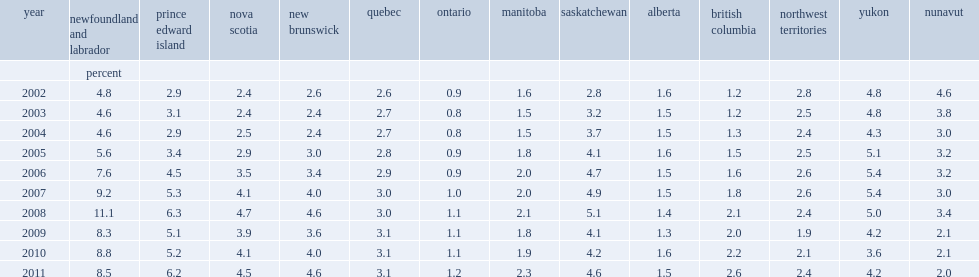What is the percentage of the total wages and salaries that is earned in 2011 by all employees residing in newfoundland and labrador coming from interprovincial employment? 8.5. What is the percentage of the total wages and salaries that is earned in 2011 by all employees residing in prince edward island coming from interprovincial employment? 6.2. What is the percentage of the total wages and salaries that is earned in 2011 by all employees residing in nova scotia coming from interprovincial employment? 4.5. What is the percentage of the total wages and salaries that is earned in 2011 by all employees residing in new brunswick coming from interprovincial employment? 4.6. 